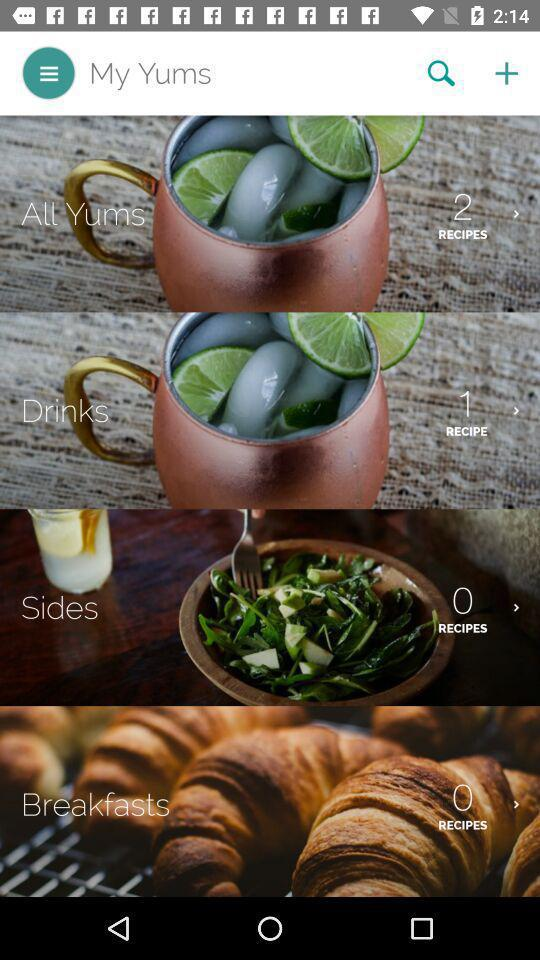What is the number of recipes in "Drinks"? There is 1 recipe. 